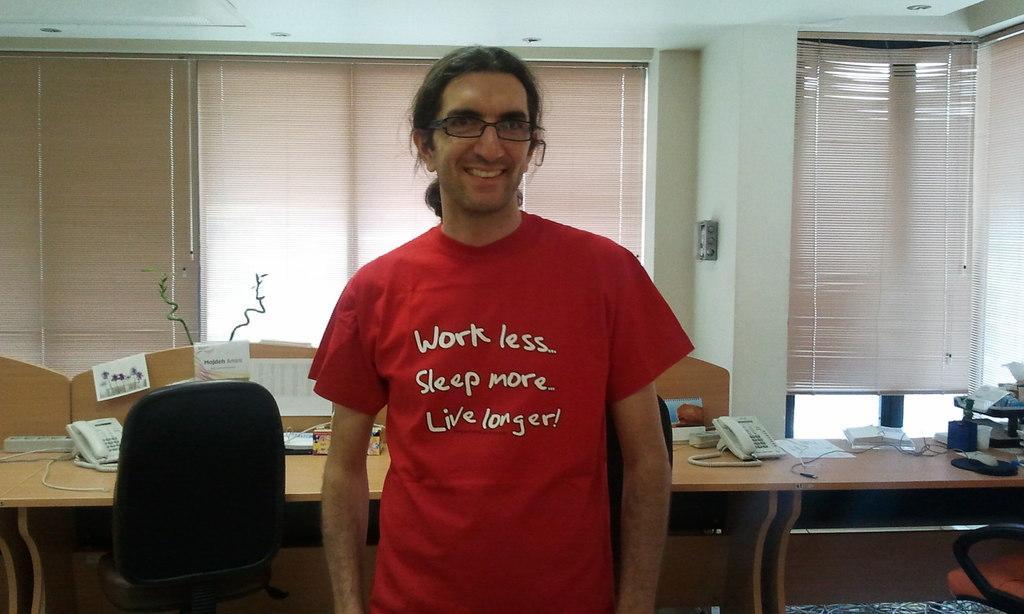In one or two sentences, can you explain what this image depicts? a person is standing wearing a red t shirt. behind him there are desks on which there are phone, papers. behind that there are windows. 